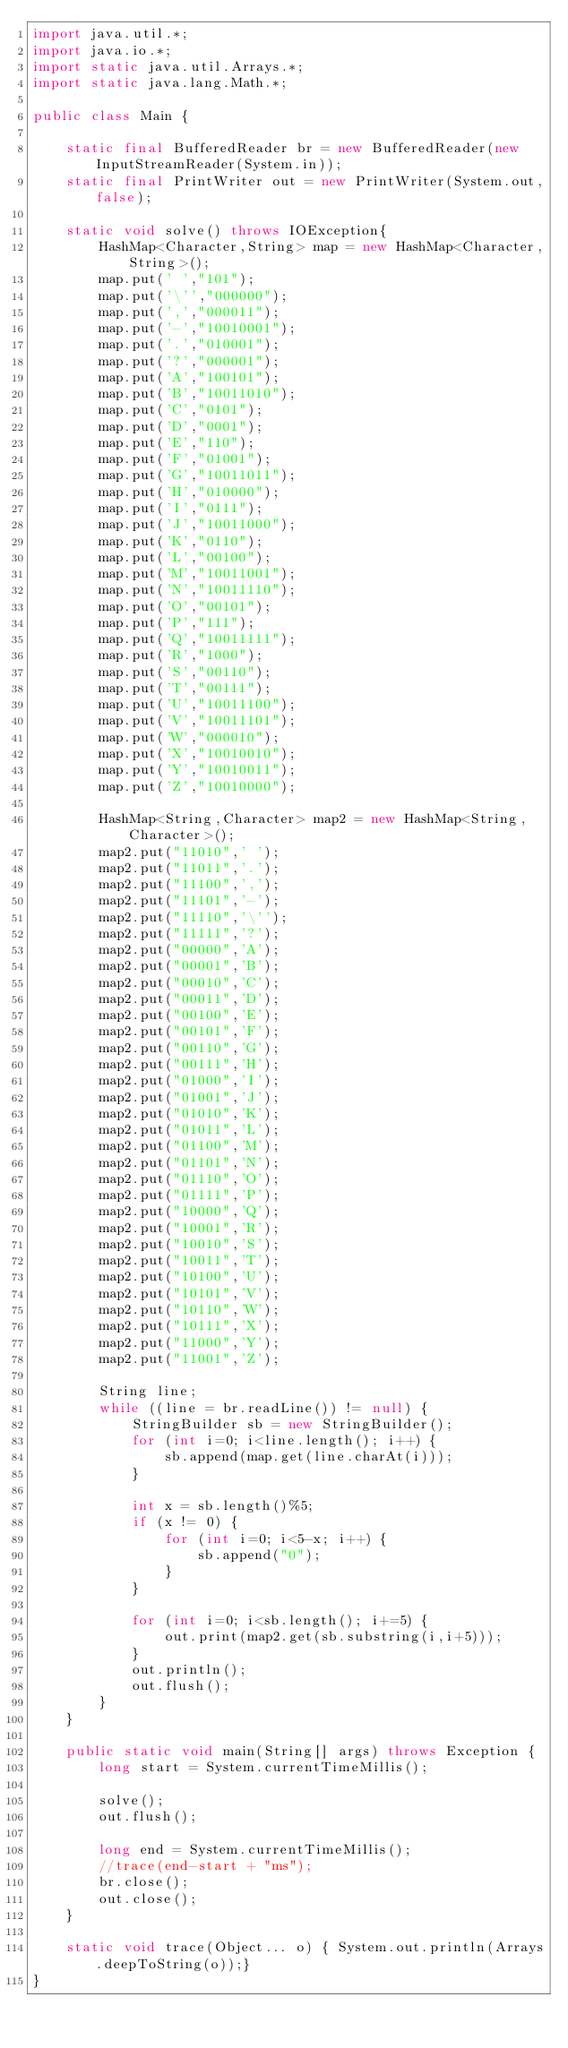<code> <loc_0><loc_0><loc_500><loc_500><_Java_>import java.util.*;
import java.io.*;
import static java.util.Arrays.*;
import static java.lang.Math.*;

public class Main {

    static final BufferedReader br = new BufferedReader(new InputStreamReader(System.in));
    static final PrintWriter out = new PrintWriter(System.out,false);

    static void solve() throws IOException{
    	HashMap<Character,String> map = new HashMap<Character,String>();
    	map.put(' ',"101");
    	map.put('\'',"000000");
    	map.put(',',"000011");
    	map.put('-',"10010001");
    	map.put('.',"010001");
    	map.put('?',"000001");
    	map.put('A',"100101");
    	map.put('B',"10011010");
    	map.put('C',"0101");
    	map.put('D',"0001");
    	map.put('E',"110");
    	map.put('F',"01001");
    	map.put('G',"10011011");
    	map.put('H',"010000");
    	map.put('I',"0111");
    	map.put('J',"10011000");
    	map.put('K',"0110");
    	map.put('L',"00100");
    	map.put('M',"10011001");
    	map.put('N',"10011110");
    	map.put('O',"00101");
    	map.put('P',"111");
    	map.put('Q',"10011111");
    	map.put('R',"1000");
    	map.put('S',"00110");
    	map.put('T',"00111");
    	map.put('U',"10011100");
    	map.put('V',"10011101");
    	map.put('W',"000010");
    	map.put('X',"10010010");
    	map.put('Y',"10010011");
    	map.put('Z',"10010000");

    	HashMap<String,Character> map2 = new HashMap<String,Character>();
    	map2.put("11010",' ');
    	map2.put("11011",'.');
    	map2.put("11100",',');
    	map2.put("11101",'-');
    	map2.put("11110",'\'');
    	map2.put("11111",'?');
    	map2.put("00000",'A');
    	map2.put("00001",'B');
    	map2.put("00010",'C');
    	map2.put("00011",'D');
    	map2.put("00100",'E');
    	map2.put("00101",'F');
    	map2.put("00110",'G');
    	map2.put("00111",'H');
    	map2.put("01000",'I');
    	map2.put("01001",'J');
    	map2.put("01010",'K');
    	map2.put("01011",'L');
    	map2.put("01100",'M');
    	map2.put("01101",'N');
    	map2.put("01110",'O');
    	map2.put("01111",'P');
    	map2.put("10000",'Q');
    	map2.put("10001",'R');
    	map2.put("10010",'S');
    	map2.put("10011",'T');
    	map2.put("10100",'U');
    	map2.put("10101",'V');
    	map2.put("10110",'W');
    	map2.put("10111",'X');
    	map2.put("11000",'Y');
    	map2.put("11001",'Z');

        String line;
        while ((line = br.readLine()) != null) {
        	StringBuilder sb = new StringBuilder();
        	for (int i=0; i<line.length(); i++) {
        		sb.append(map.get(line.charAt(i)));
        	}

        	int x = sb.length()%5;
        	if (x != 0) {
        		for (int i=0; i<5-x; i++) {
        			sb.append("0");
        		}
        	}

        	for (int i=0; i<sb.length(); i+=5) {
        		out.print(map2.get(sb.substring(i,i+5)));
        	}
        	out.println();
        	out.flush();
        }
    }

    public static void main(String[] args) throws Exception {
        long start = System.currentTimeMillis();

        solve();
        out.flush();

        long end = System.currentTimeMillis();
        //trace(end-start + "ms");
        br.close();
        out.close();
    }

    static void trace(Object... o) { System.out.println(Arrays.deepToString(o));}
}</code> 